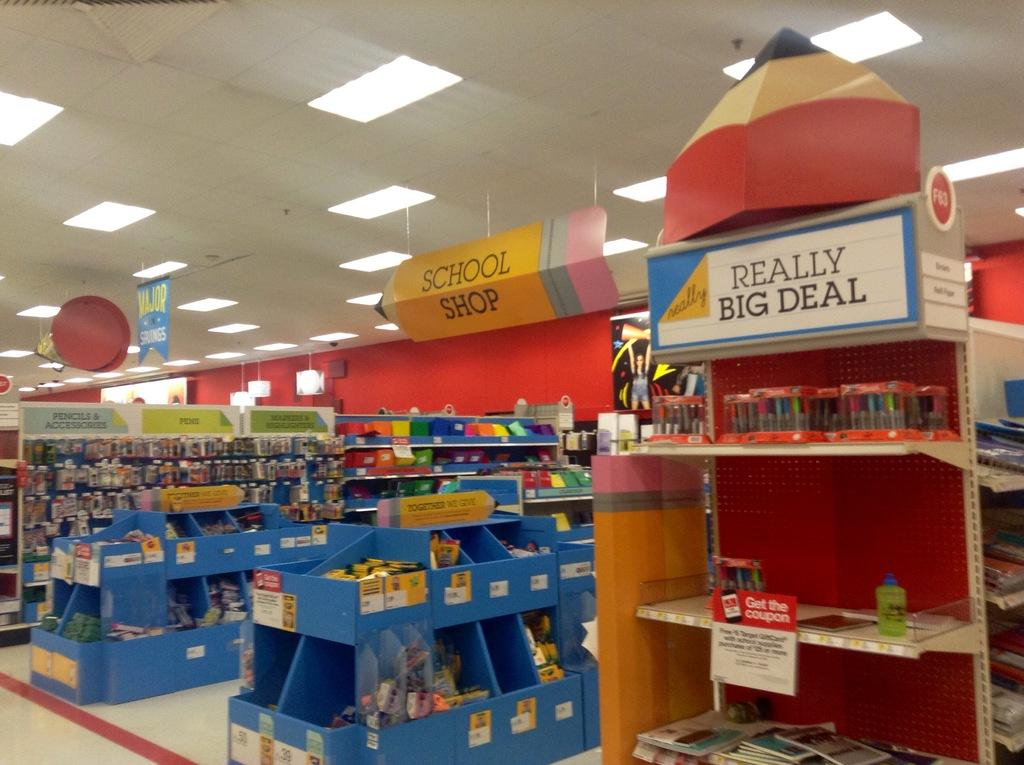Provide a one-sentence caption for the provided image. a display section at a store with signs saying School shop and REALLY BIG DEAL. 